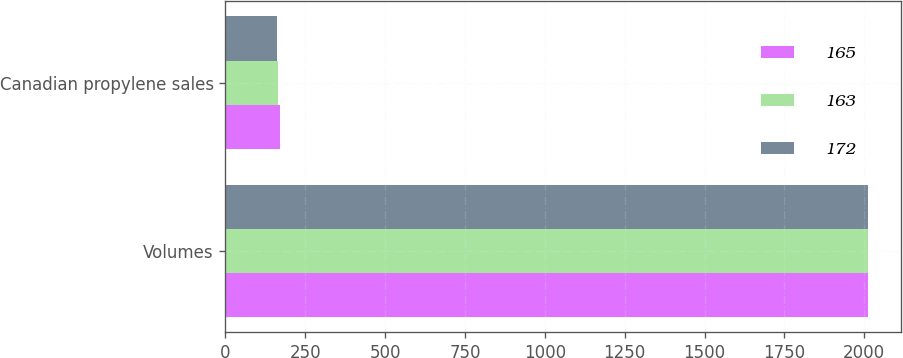<chart> <loc_0><loc_0><loc_500><loc_500><stacked_bar_chart><ecel><fcel>Volumes<fcel>Canadian propylene sales<nl><fcel>165<fcel>2013<fcel>172<nl><fcel>163<fcel>2012<fcel>165<nl><fcel>172<fcel>2011<fcel>163<nl></chart> 